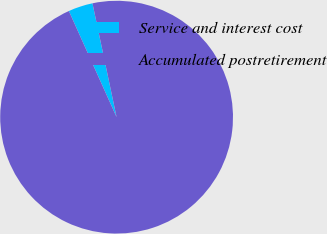Convert chart to OTSL. <chart><loc_0><loc_0><loc_500><loc_500><pie_chart><fcel>Service and interest cost<fcel>Accumulated postretirement<nl><fcel>3.4%<fcel>96.6%<nl></chart> 